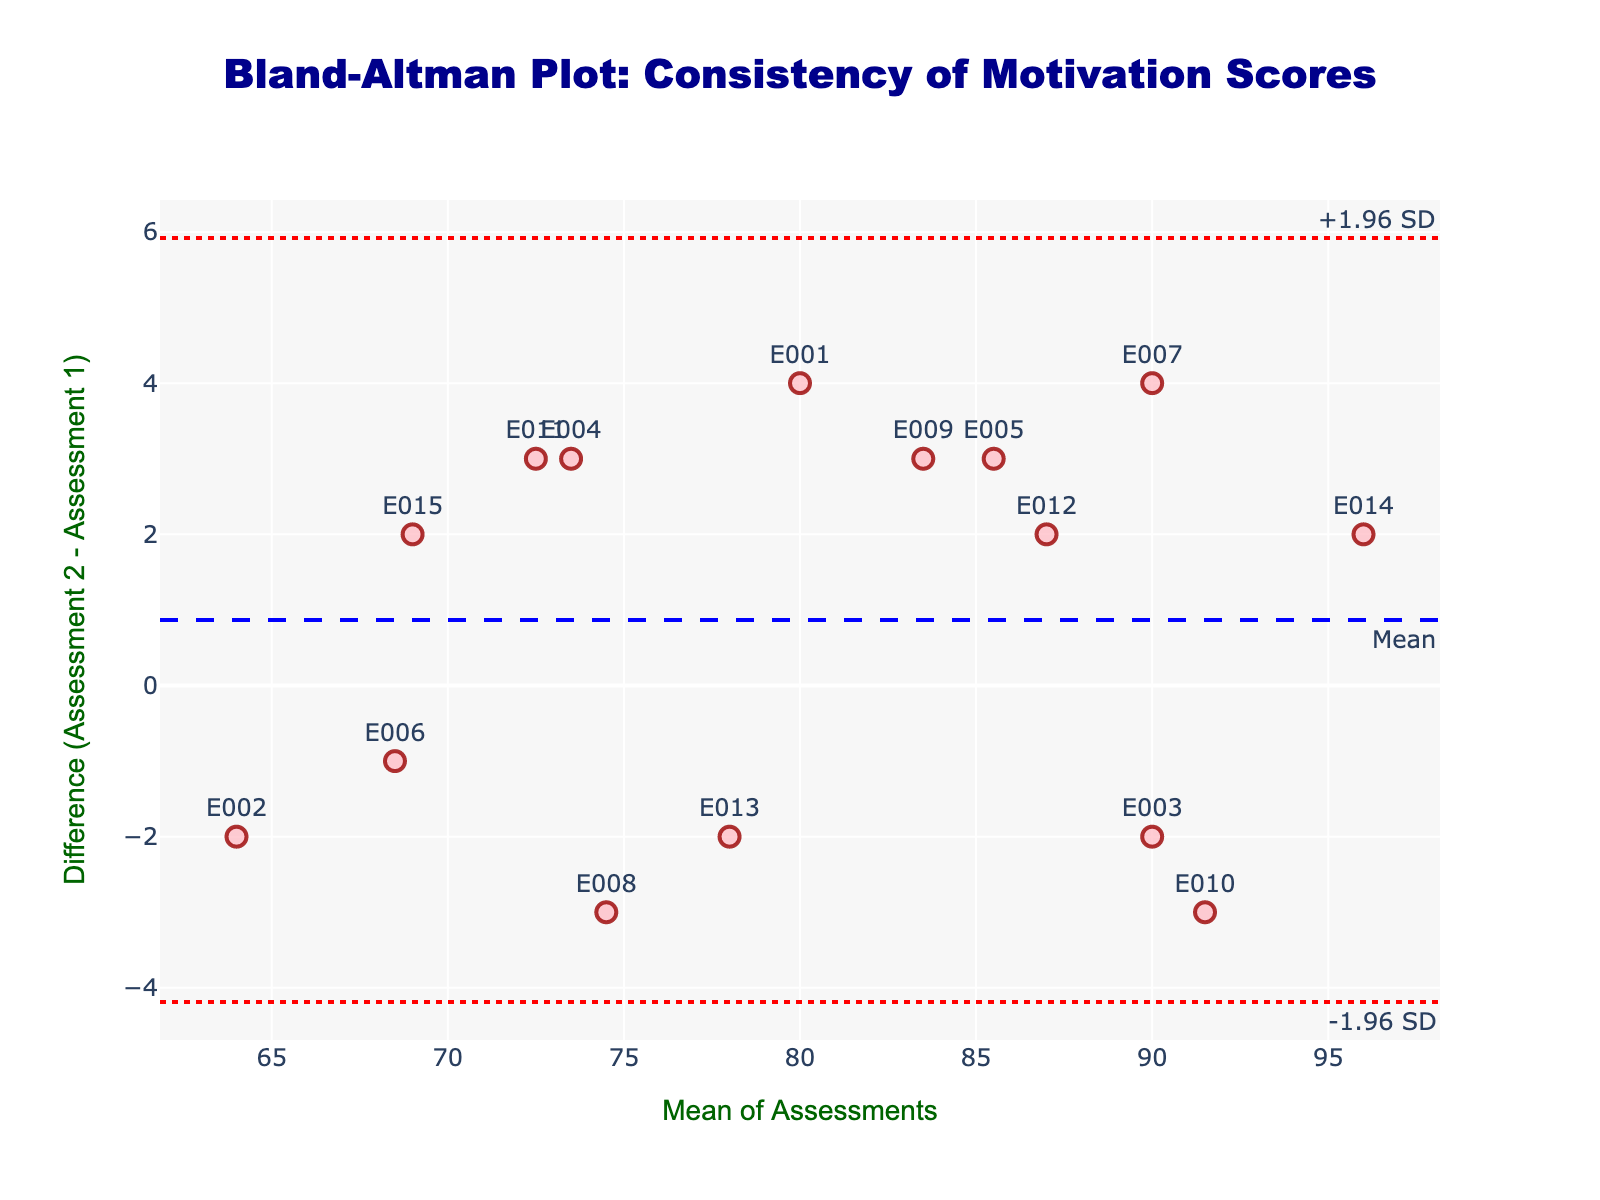What is the title of the plot? The title of the plot is usually displayed at the top and provides a brief description of the plot. The provided code sets the title as 'Bland-Altman Plot: Consistency of Motivation Scores'.
Answer: Bland-Altman Plot: Consistency of Motivation Scores What does the x-axis represent in this plot? The x-axis title is given as "Mean of Assessments". It represents the average value of Assessment 1 and Assessment 2 for each employee.
Answer: Mean of Assessments What does the y-axis represent in this plot? The y-axis title is given as "Difference (Assessment 2 - Assessment 1)". It represents the difference between the scores of the second assessment and the first assessment for each employee.
Answer: Difference (Assessment 2 - Assessment 1) How many data points (employees) are plotted on this figure? Each scatter point represents one employee, and looking at the data provided, there are 15 employees listed (E001 to E015).
Answer: 15 What is the mean difference between the two assessments? The mean difference line is annotated in the plot with "Mean". This line is created using the average difference between Assessment 2 and Assessment 1 across all employees.
Answer: Close to zero What do the dashed blue and dotted red lines represent? The dashed blue line represents the mean difference between the two assessments, while the dotted red lines represent the limits of agreement (+1.96 SD and -1.96 SD).
Answer: The mean difference and the limits of agreement (+1.96 SD and -1.96 SD) Which employees have the largest difference between their two assessments? The largest difference is indicated by the point farthest from the mean difference line on the y-axis. By looking at the scatter points and their labels, we can identify that employee E014 has one of the largest differences.
Answer: E014 Is there an indication that any employee's scores fall outside the limits of agreement? If so, which ones? Points that fall outside the dotted red lines (+1.96 SD and -1.96 SD) are considered outside the limits of agreement. By checking the scatter points against these lines, it can be observed that no points fall outside the limits of agreement.
Answer: No Are the score differences more evenly spread around the mean line or skewed to one side? Observing the distribution of points above and below the mean difference line (dashed blue line), the differences appear to be relatively evenly spread, which implies no strong skewness.
Answer: Evenly spread 